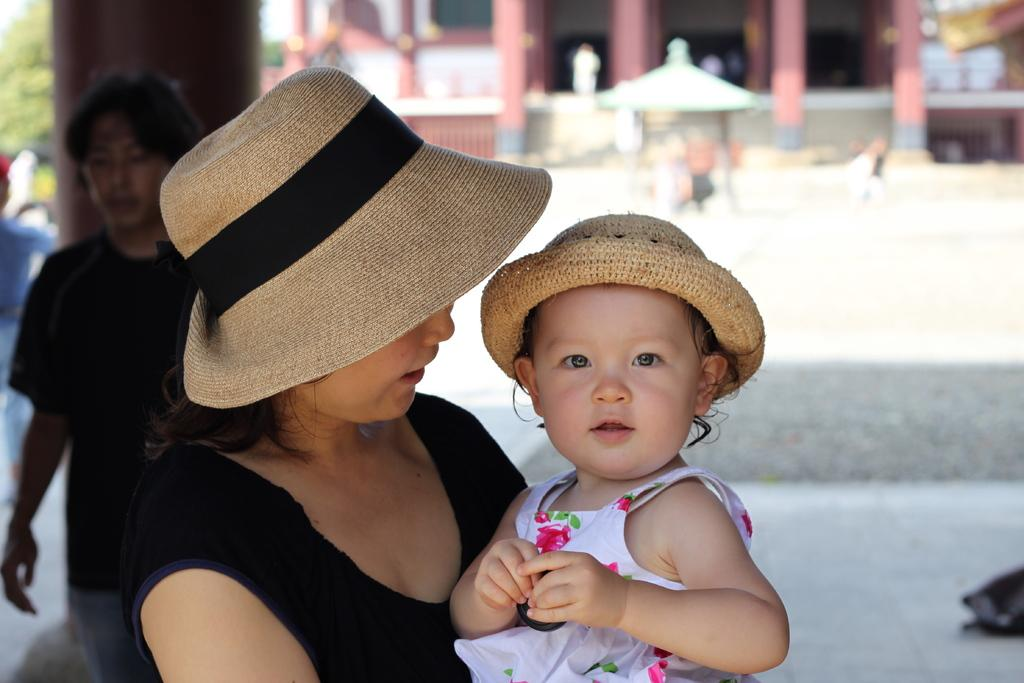How many people are in the image? There are people in the image, but the exact number is not specified. What is the woman holding in the image? One woman is holding a baby in the image. What can be seen in the background of the image? There is a building and trees visible in the background. What is visible at the bottom of the image? The ground is visible in the image. What is the toad arguing about with the accountant in the image? There is no toad or accountant present in the image. 